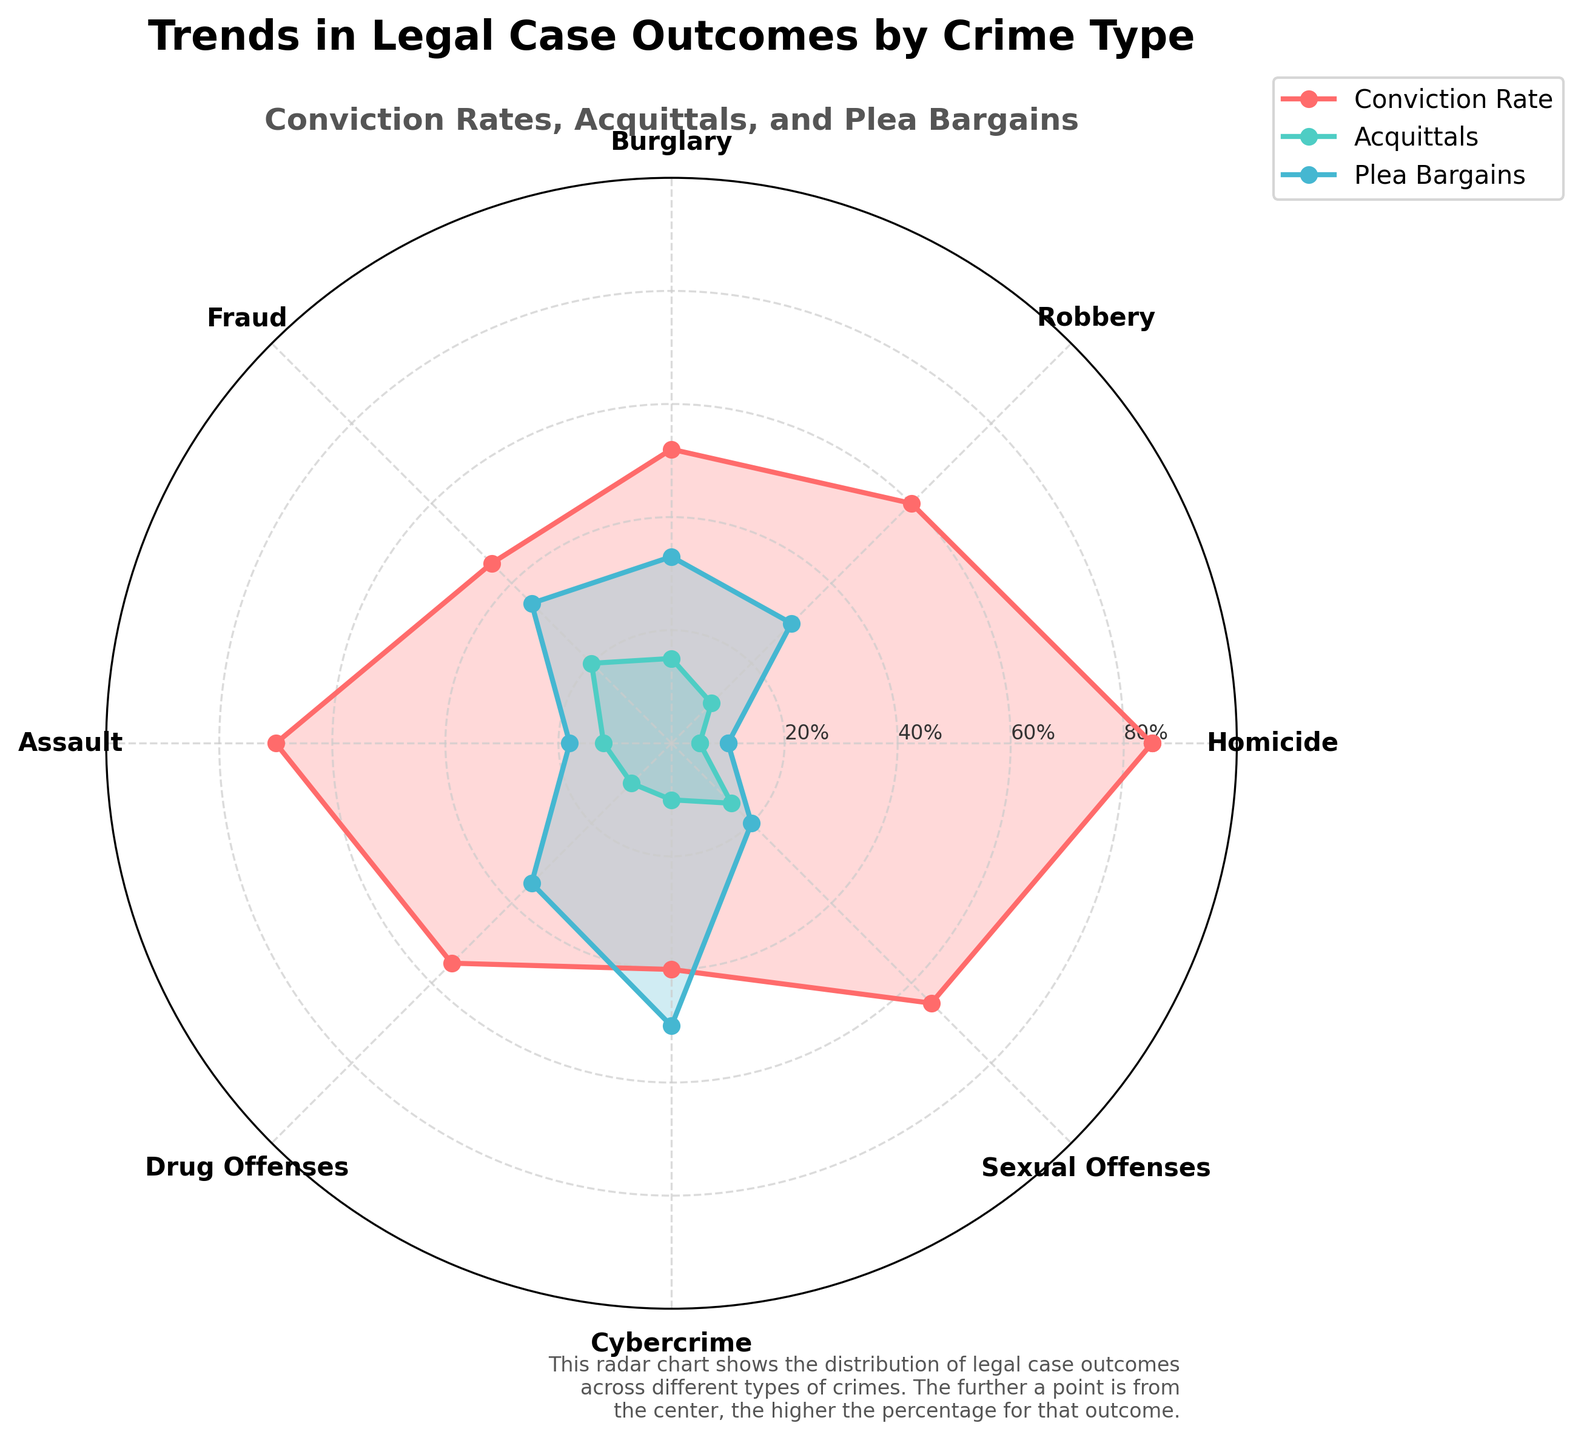What is the title of the radar chart? Refer to the top of the chart where the title is prominently displayed. This helps identify the primary topic of the figure.
Answer: Trends in Legal Case Outcomes by Crime Type What are the three outcomes represented in the radar chart? Identify the legends or labels used to denote the different types of outcomes in the chart: Conviction Rates, Acquittals, and Plea Bargains.
Answer: Conviction Rates, Acquittals, and Plea Bargains Which crime type has the highest conviction rate? Locate the highest point in the 'Conviction Rate' series on the radar chart and check the corresponding crime type.
Answer: Homicide How do the Plea Bargains for Fraud compare to those for Cybercrime? Compare the Plea Bargains between Fraud and Cybercrime by locating their respective points and assessing the difference visually. Cybercrime should have a much higher value than Fraud.
Answer: Cybercrime has a higher rate of Plea Bargains than Fraud What is the overall trend in Acquittals rates across different crime types? Observe the points marked for Acquittals across the chart. Note if there's any significant rise or fall.
Answer: Relatively consistent around 10-20% Which crime type has the lowest percentage for Conviction Rates, and what is that percentage? Find the lowest point in the 'Conviction Rate' series and check the corresponding crime type and its value.
Answer: Cybercrime, 40% For which crime type is the difference between Conviction Rates and Plea Bargains the smallest? Calculate the differences between Conviction Rates and Plea Bargains for each crime type and determine the smallest.
Answer: Assault (70-18 = 52, difference = 52%) How does Robbery compare to Burglary in terms of Acquittals? Look at the points for Robbery and Burglary in the Acquittals series and compare their values.
Answer: Robbery has a lower Acquittal rate than Burglary Which crime type has the closest rates for Conviction and Plea Bargains? Determine the crime type where Conviction Rates and Plea Bargains percentages are closest to each other.
Answer: Fraud (45% Conviction, 35% Plea Bargains) What can you infer about the Conviction Rates for aggressive crimes like Homicide and Assault compared to non-violent crimes like Fraud and Cybercrime? Compare the positions of Homicide and Assault Conviction Rates with those of Fraud and Cybercrime on the radar chart to determine if there's a trend.
Answer: Aggressive crimes have higher Conviction Rates than non-violent crimes 